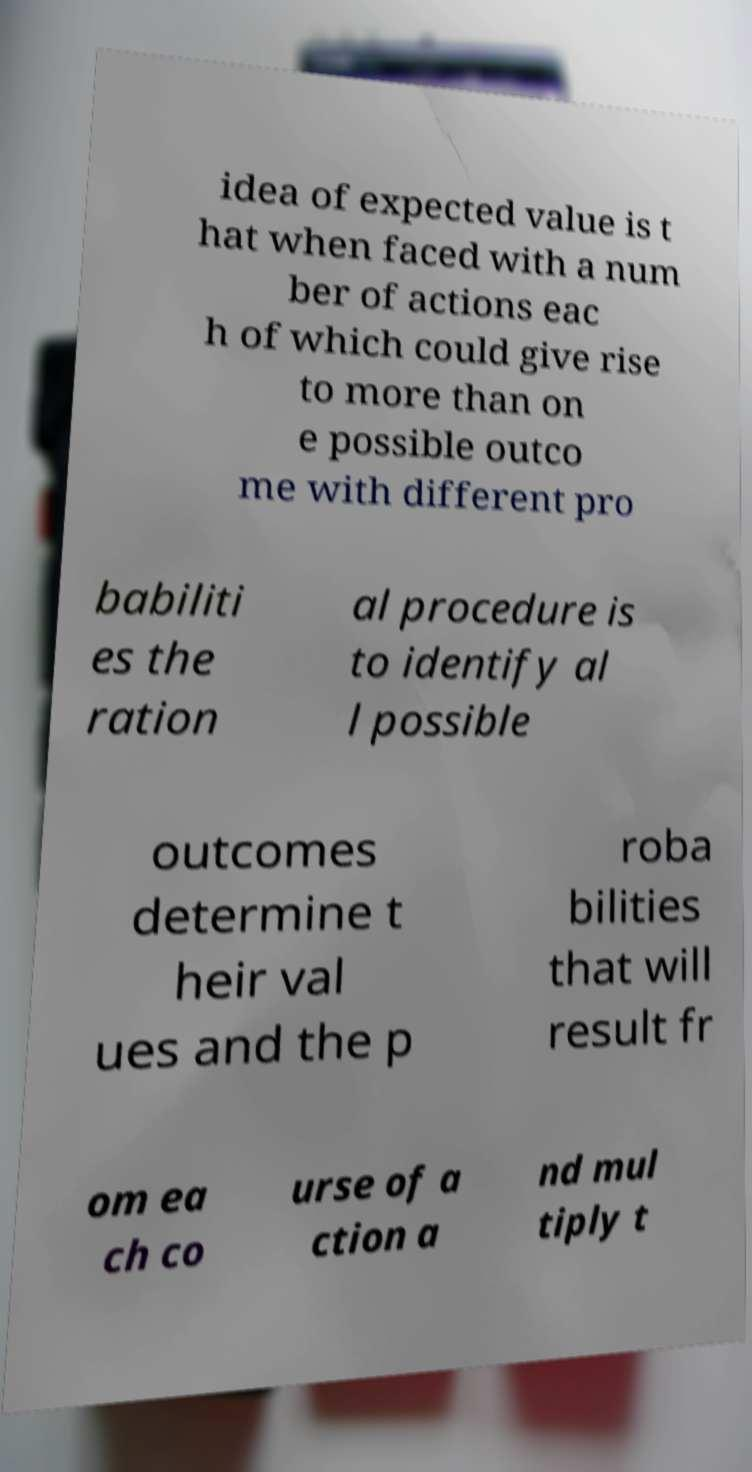Please read and relay the text visible in this image. What does it say? idea of expected value is t hat when faced with a num ber of actions eac h of which could give rise to more than on e possible outco me with different pro babiliti es the ration al procedure is to identify al l possible outcomes determine t heir val ues and the p roba bilities that will result fr om ea ch co urse of a ction a nd mul tiply t 